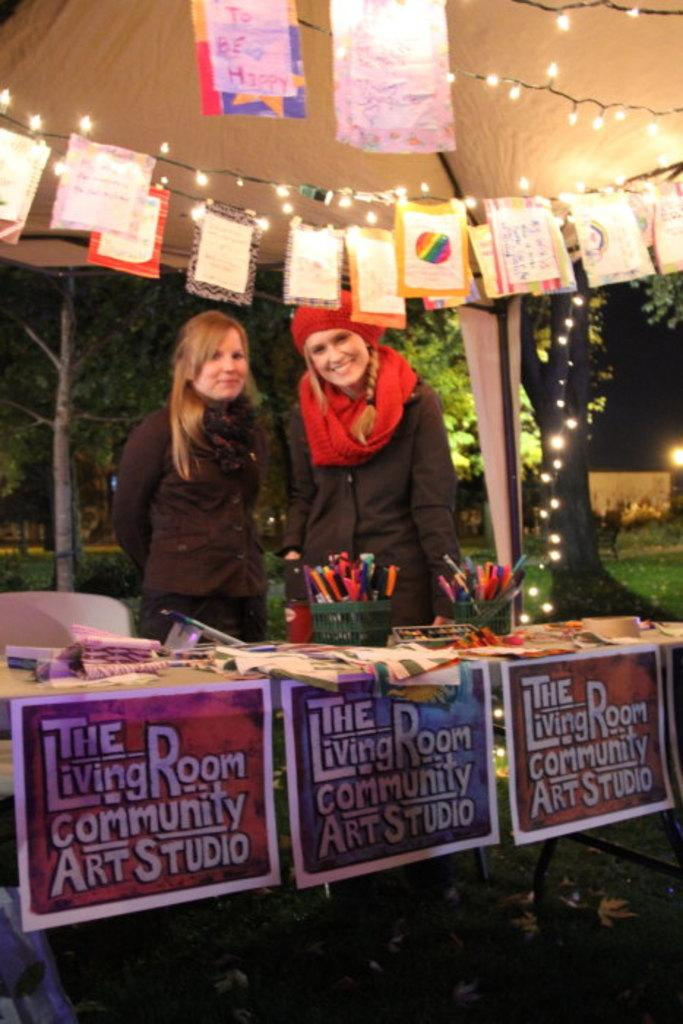How many people are in the image? There are 2 women in the image. What is the setting of the image? The women are standing on the grass and are under a tent. What can be seen above the women in the image? There are greeting cards above the women. Can you tell me where the nearest store is in the image? There is no store present in the image. Are there any lizards visible in the image? There are no lizards visible in the image. 